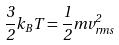<formula> <loc_0><loc_0><loc_500><loc_500>\frac { 3 } { 2 } k _ { B } T = \frac { 1 } { 2 } m v _ { r m s } ^ { 2 }</formula> 